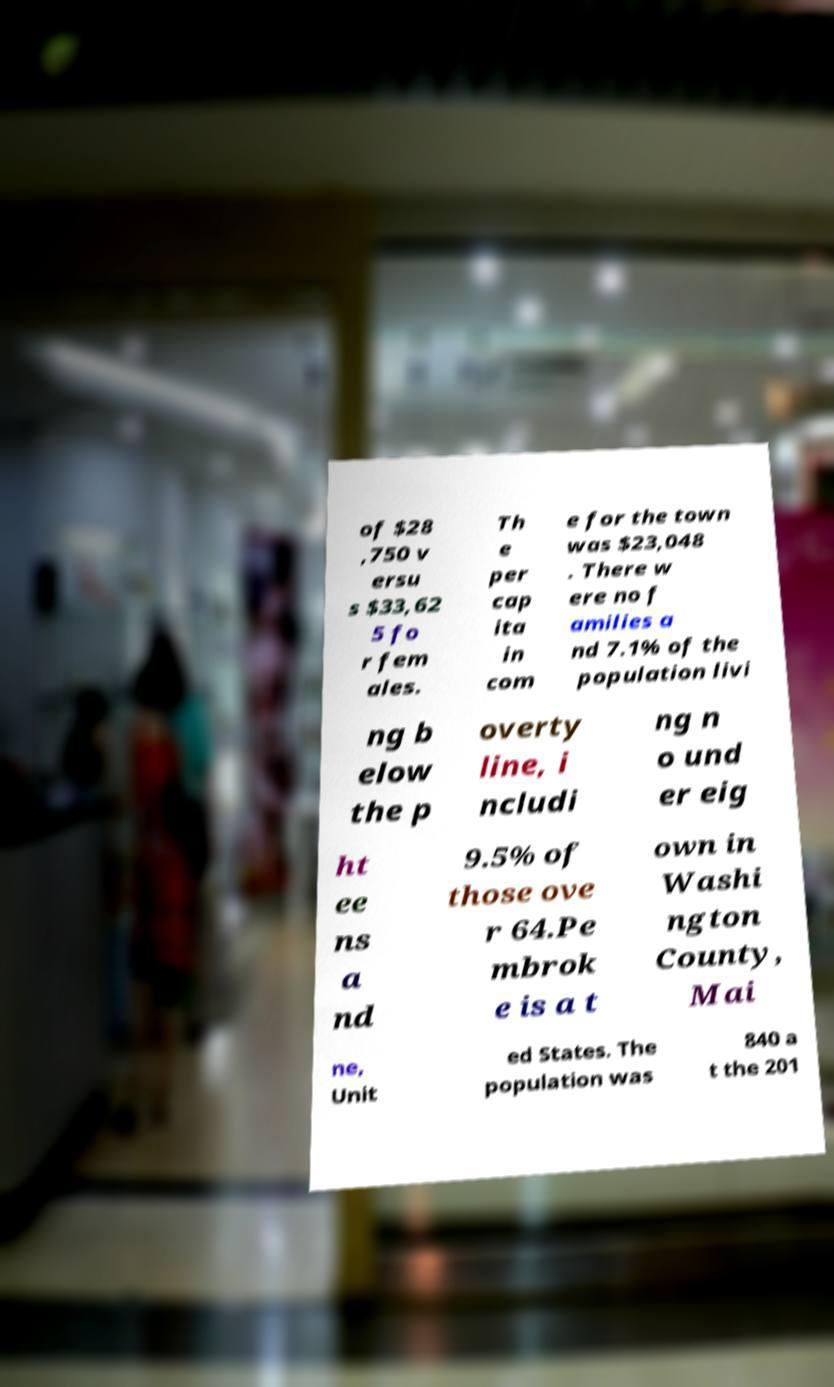Can you read and provide the text displayed in the image?This photo seems to have some interesting text. Can you extract and type it out for me? of $28 ,750 v ersu s $33,62 5 fo r fem ales. Th e per cap ita in com e for the town was $23,048 . There w ere no f amilies a nd 7.1% of the population livi ng b elow the p overty line, i ncludi ng n o und er eig ht ee ns a nd 9.5% of those ove r 64.Pe mbrok e is a t own in Washi ngton County, Mai ne, Unit ed States. The population was 840 a t the 201 